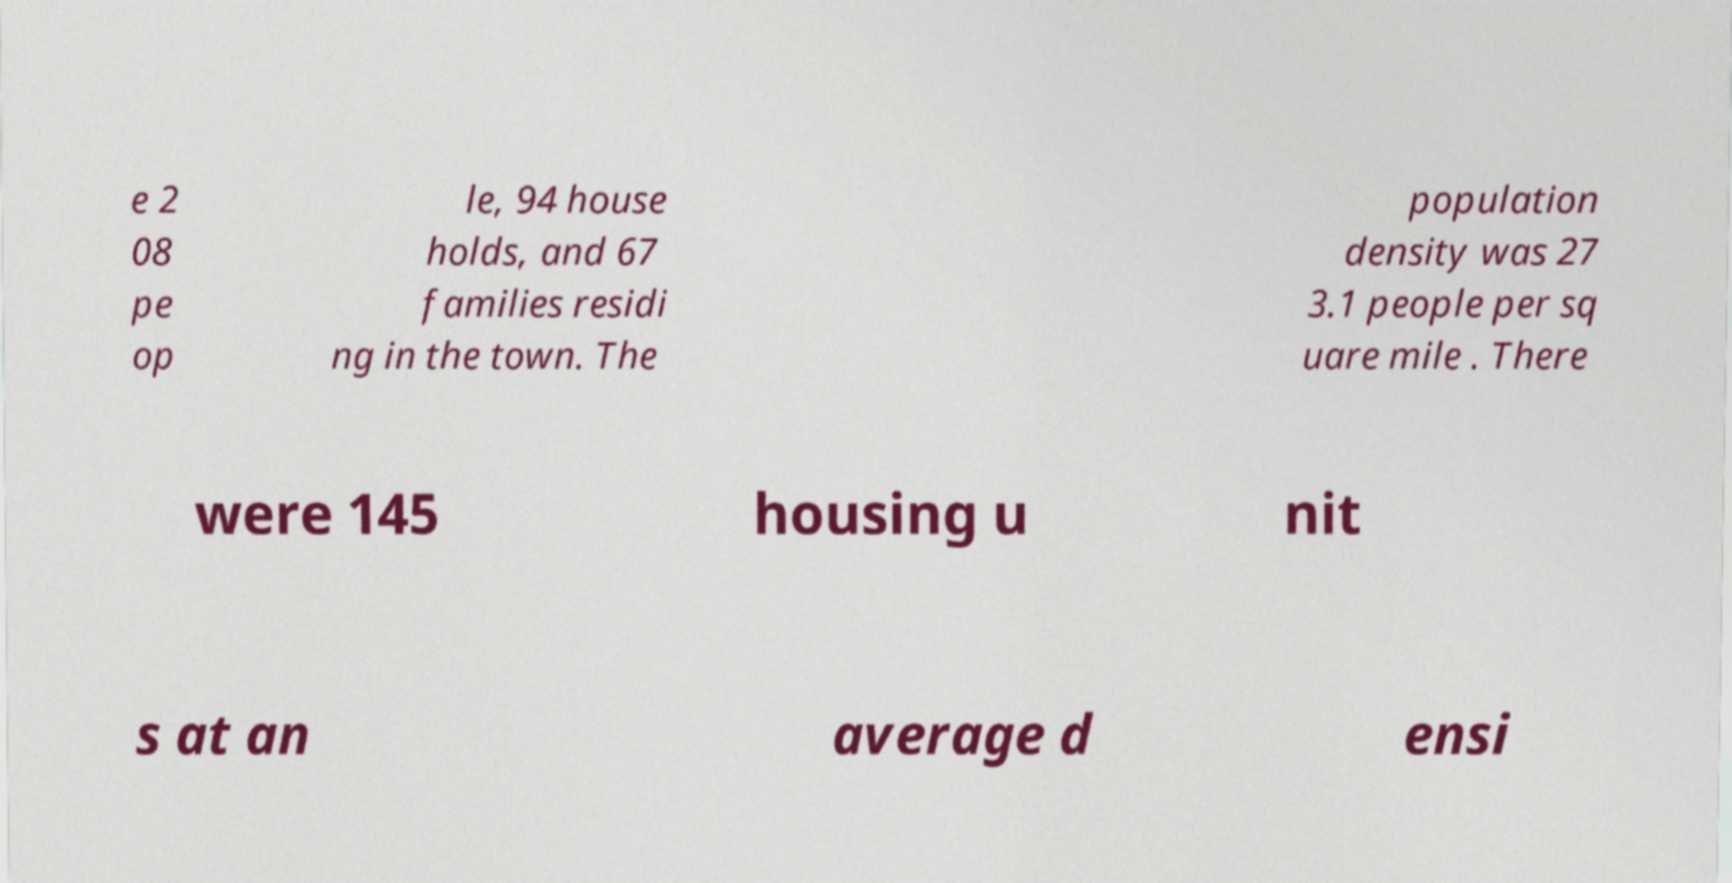Please read and relay the text visible in this image. What does it say? e 2 08 pe op le, 94 house holds, and 67 families residi ng in the town. The population density was 27 3.1 people per sq uare mile . There were 145 housing u nit s at an average d ensi 